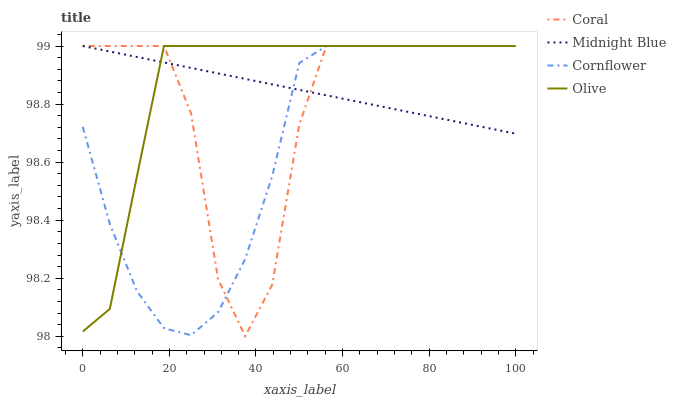Does Cornflower have the minimum area under the curve?
Answer yes or no. Yes. Does Olive have the maximum area under the curve?
Answer yes or no. Yes. Does Coral have the minimum area under the curve?
Answer yes or no. No. Does Coral have the maximum area under the curve?
Answer yes or no. No. Is Midnight Blue the smoothest?
Answer yes or no. Yes. Is Coral the roughest?
Answer yes or no. Yes. Is Cornflower the smoothest?
Answer yes or no. No. Is Cornflower the roughest?
Answer yes or no. No. Does Coral have the lowest value?
Answer yes or no. Yes. Does Cornflower have the lowest value?
Answer yes or no. No. Does Midnight Blue have the highest value?
Answer yes or no. Yes. Does Coral intersect Olive?
Answer yes or no. Yes. Is Coral less than Olive?
Answer yes or no. No. Is Coral greater than Olive?
Answer yes or no. No. 